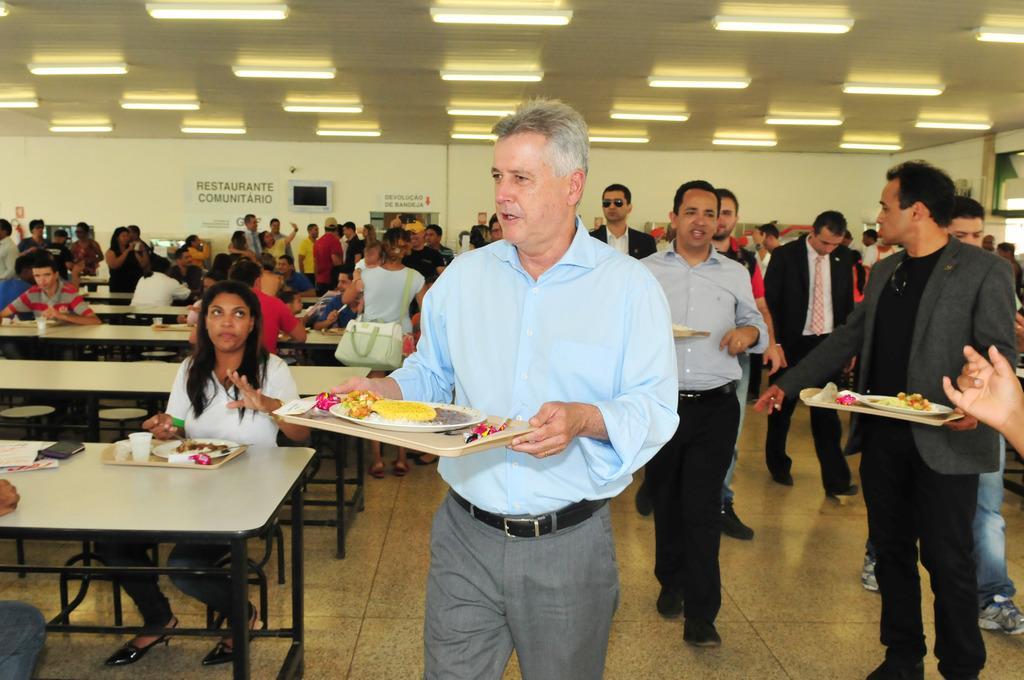In one or two sentences, can you explain what this image depicts? In the image we can see there are people who are standing on the floor and on the other side there are people who are sitting on the benches and they are holding a tray which is filled with food items. 